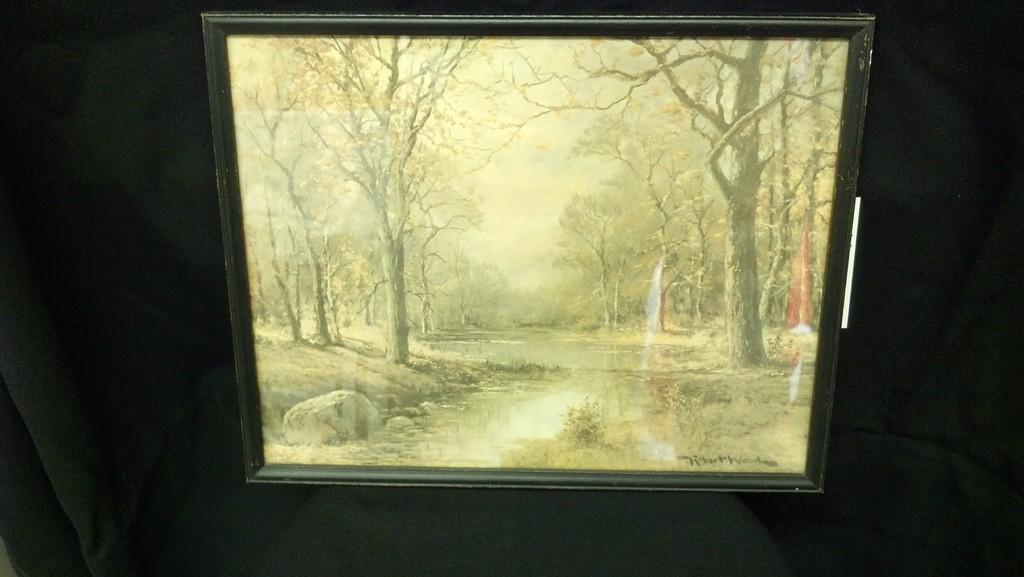Could you give a brief overview of what you see in this image? There is a frame on the black surface. On this frame we can see trees, water, rocks, and sky. 